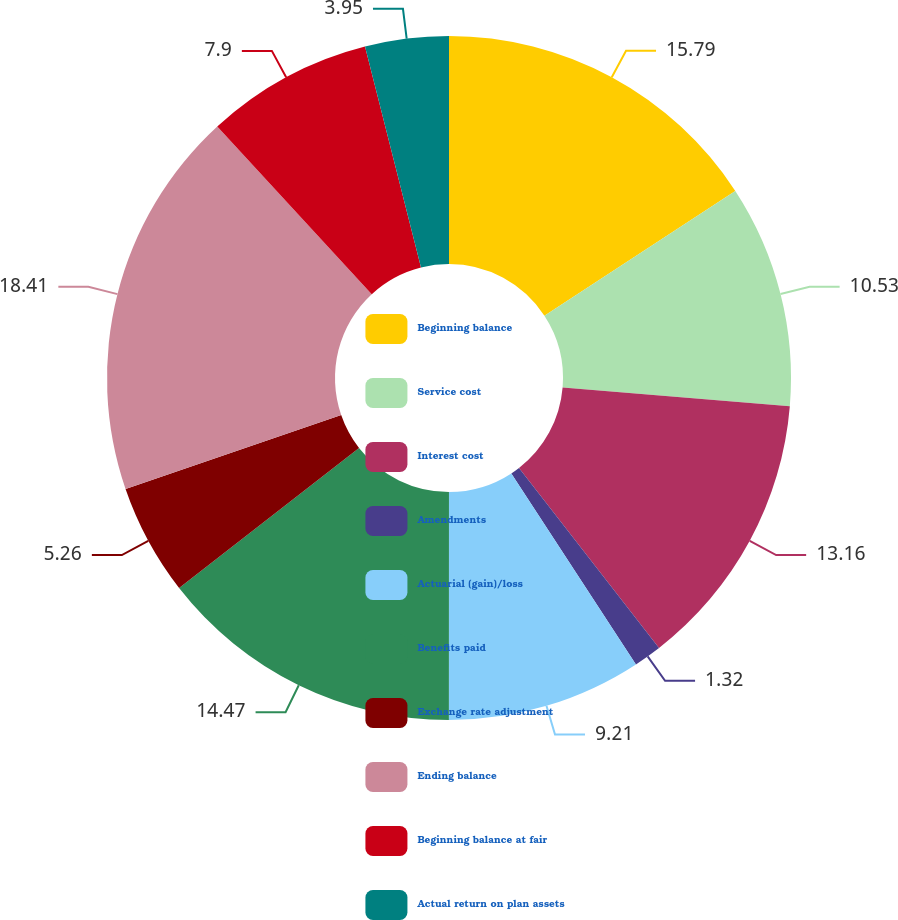Convert chart to OTSL. <chart><loc_0><loc_0><loc_500><loc_500><pie_chart><fcel>Beginning balance<fcel>Service cost<fcel>Interest cost<fcel>Amendments<fcel>Actuarial (gain)/loss<fcel>Benefits paid<fcel>Exchange rate adjustment<fcel>Ending balance<fcel>Beginning balance at fair<fcel>Actual return on plan assets<nl><fcel>15.79%<fcel>10.53%<fcel>13.16%<fcel>1.32%<fcel>9.21%<fcel>14.47%<fcel>5.26%<fcel>18.42%<fcel>7.9%<fcel>3.95%<nl></chart> 